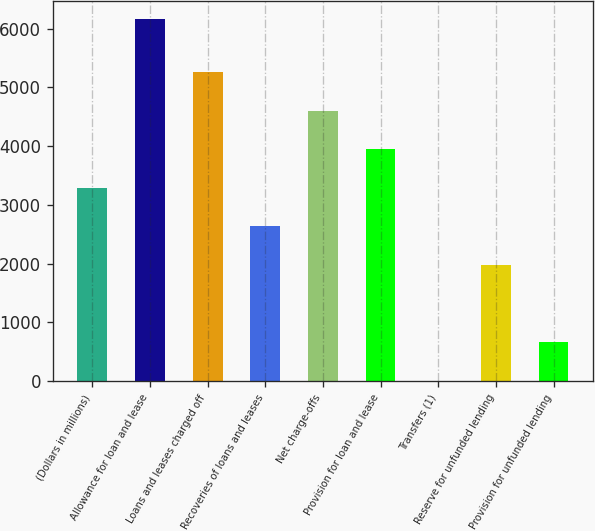Convert chart to OTSL. <chart><loc_0><loc_0><loc_500><loc_500><bar_chart><fcel>(Dollars in millions)<fcel>Allowance for loan and lease<fcel>Loans and leases charged off<fcel>Recoveries of loans and leases<fcel>Net charge-offs<fcel>Provision for loan and lease<fcel>Transfers (1)<fcel>Reserve for unfunded lending<fcel>Provision for unfunded lending<nl><fcel>3292<fcel>6163<fcel>5264.2<fcel>2634.6<fcel>4606.8<fcel>3949.4<fcel>5<fcel>1977.2<fcel>662.4<nl></chart> 